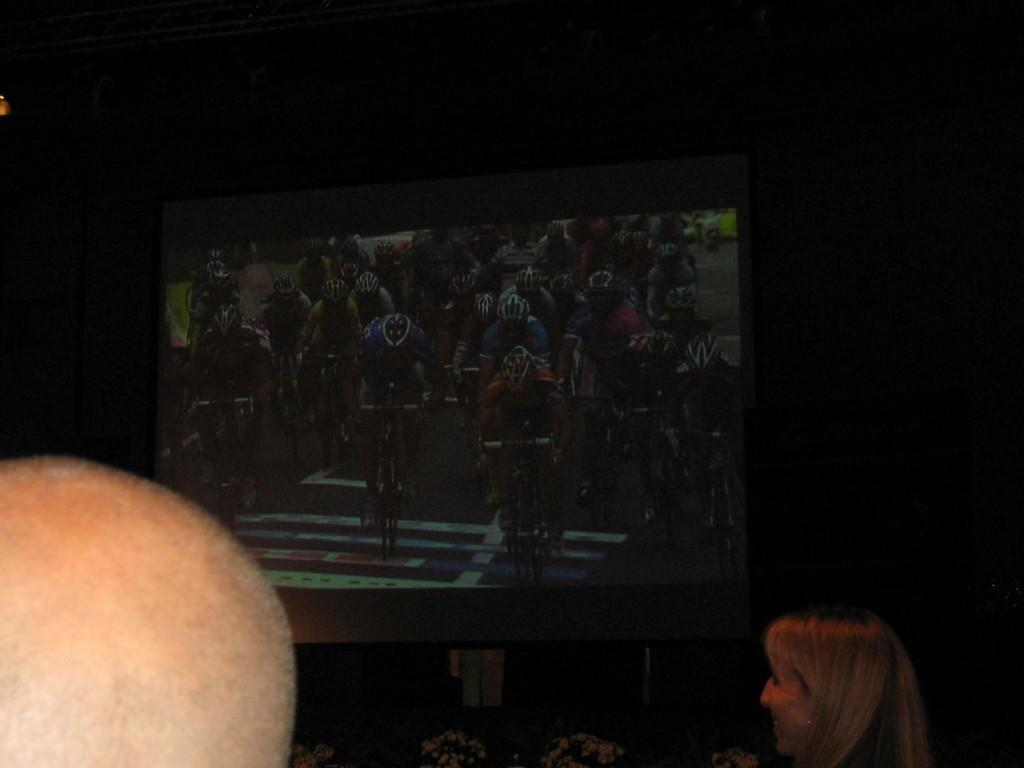What is the main subject of the image? There is a person in the image. What can be seen on the screen in the image? The screen displays people riding bicycles. What is the color of the background in the image? The background of the image is dark. Can you tell me how many hens are visible on the screen in the image? There are no hens visible on the screen in the image; the screen displays people riding bicycles. What type of hook is being used by the person in the image? There is no hook present in the image; the person is not engaged in any activity that would require a hook. 